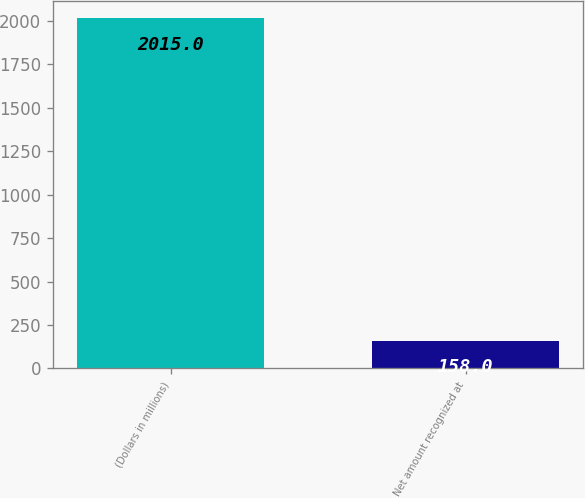Convert chart to OTSL. <chart><loc_0><loc_0><loc_500><loc_500><bar_chart><fcel>(Dollars in millions)<fcel>Net amount recognized at<nl><fcel>2015<fcel>158<nl></chart> 